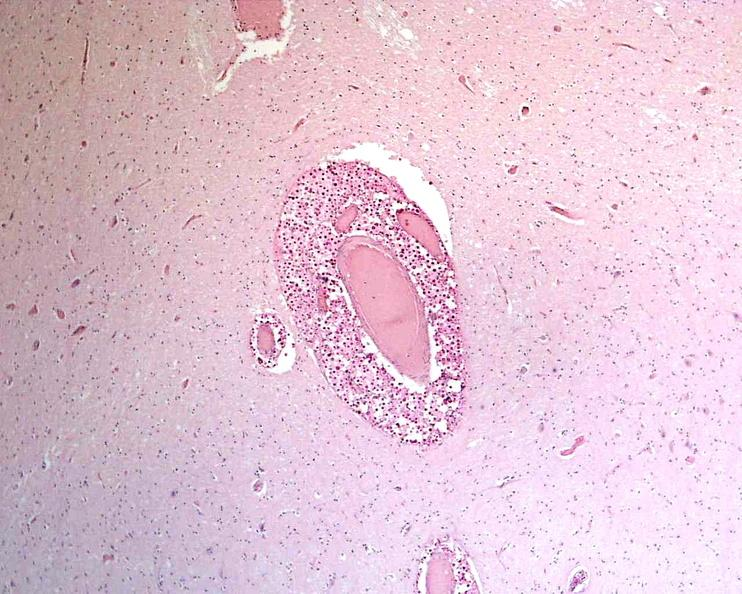do this stain?
Answer the question using a single word or phrase. No 